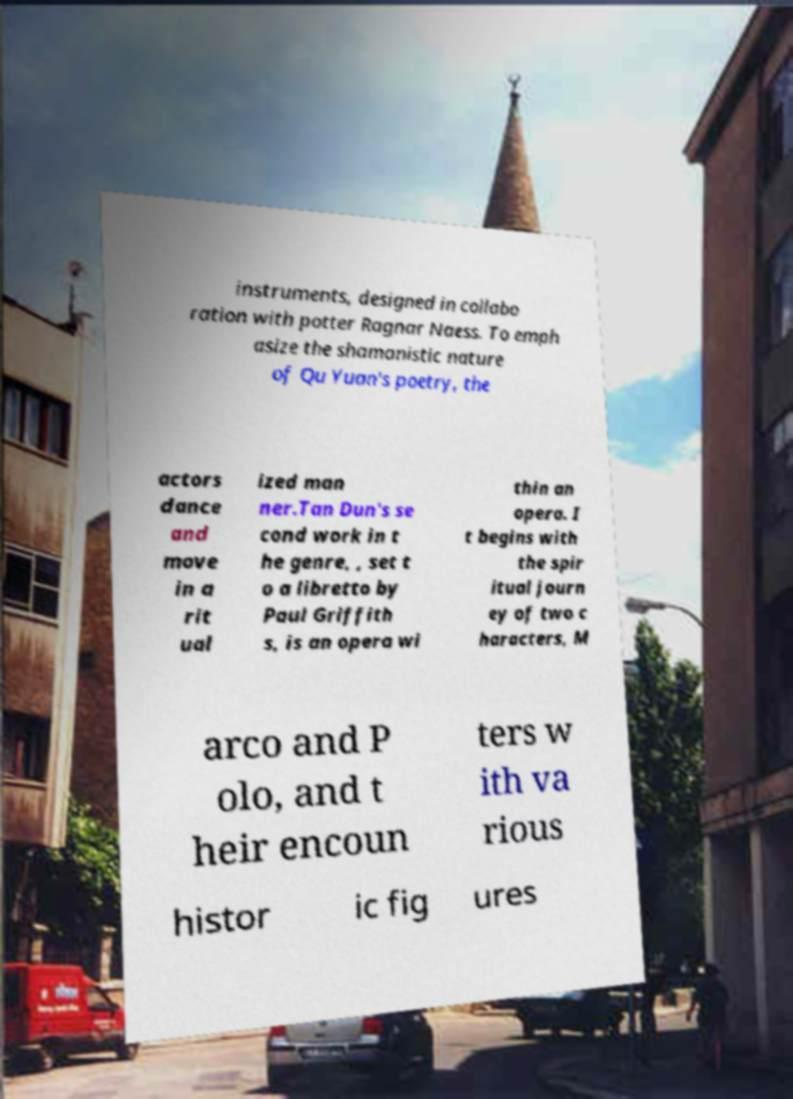There's text embedded in this image that I need extracted. Can you transcribe it verbatim? instruments, designed in collabo ration with potter Ragnar Naess. To emph asize the shamanistic nature of Qu Yuan's poetry, the actors dance and move in a rit ual ized man ner.Tan Dun's se cond work in t he genre, , set t o a libretto by Paul Griffith s, is an opera wi thin an opera. I t begins with the spir itual journ ey of two c haracters, M arco and P olo, and t heir encoun ters w ith va rious histor ic fig ures 